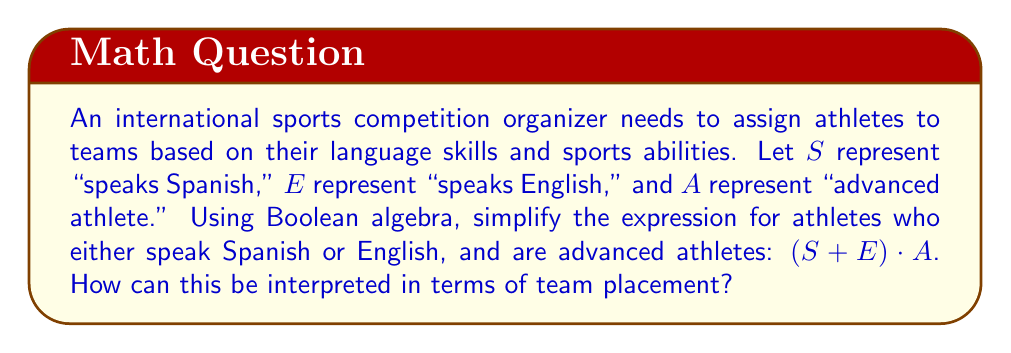What is the answer to this math problem? To simplify the given Boolean expression $(S + E) \cdot A$, we can follow these steps:

1. The expression is already in its simplest form, as it cannot be further reduced using Boolean algebra laws.

2. Let's interpret each part of the expression:
   - $S + E$ represents athletes who speak Spanish OR English (or both)
   - $A$ represents advanced athletes
   - The dot operation $\cdot$ represents AND

3. Therefore, $(S + E) \cdot A$ means:
   (Speaks Spanish OR Speaks English) AND Is an advanced athlete

4. This can be interpreted as:
   Athletes who are advanced AND can communicate in either Spanish or English (or both)

5. In terms of team placement, this expression would help identify athletes who:
   a) Have high skill levels (advanced athletes)
   b) Can communicate effectively with Spanish or English-speaking teammates and coaches

6. This Boolean expression optimizes athlete placement by ensuring that teams have skilled players who can also communicate effectively, which is crucial for international competitions where multiple languages may be spoken.
Answer: $(S + E) \cdot A$: Advanced athletes who speak Spanish or English 